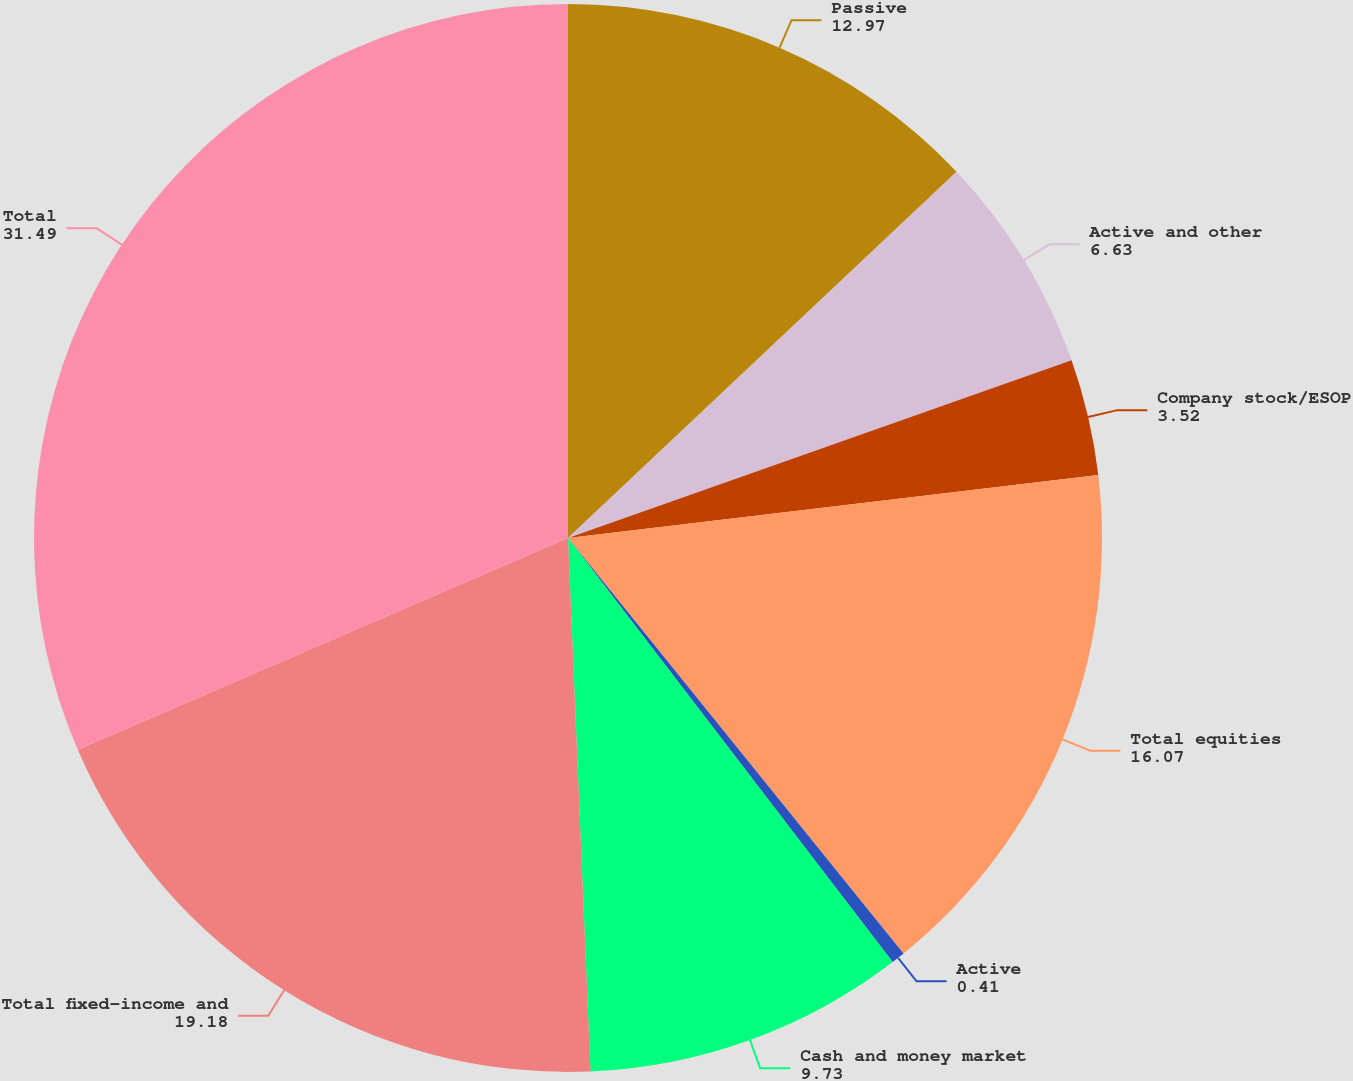<chart> <loc_0><loc_0><loc_500><loc_500><pie_chart><fcel>Passive<fcel>Active and other<fcel>Company stock/ESOP<fcel>Total equities<fcel>Active<fcel>Cash and money market<fcel>Total fixed-income and<fcel>Total<nl><fcel>12.97%<fcel>6.63%<fcel>3.52%<fcel>16.07%<fcel>0.41%<fcel>9.73%<fcel>19.18%<fcel>31.49%<nl></chart> 